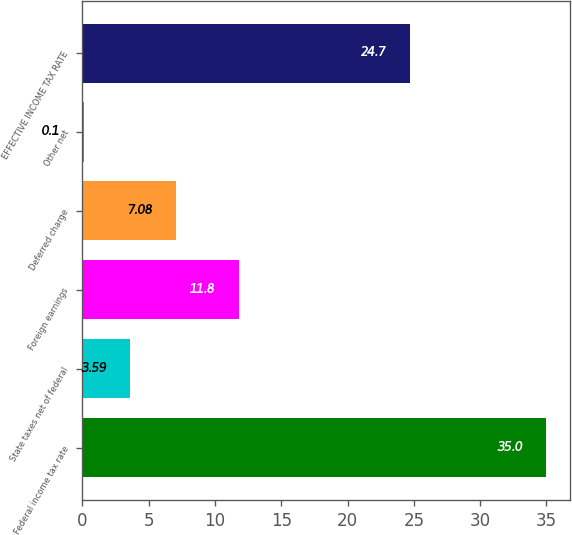Convert chart to OTSL. <chart><loc_0><loc_0><loc_500><loc_500><bar_chart><fcel>Federal income tax rate<fcel>State taxes net of federal<fcel>Foreign earnings<fcel>Deferred charge<fcel>Other net<fcel>EFFECTIVE INCOME TAX RATE<nl><fcel>35<fcel>3.59<fcel>11.8<fcel>7.08<fcel>0.1<fcel>24.7<nl></chart> 